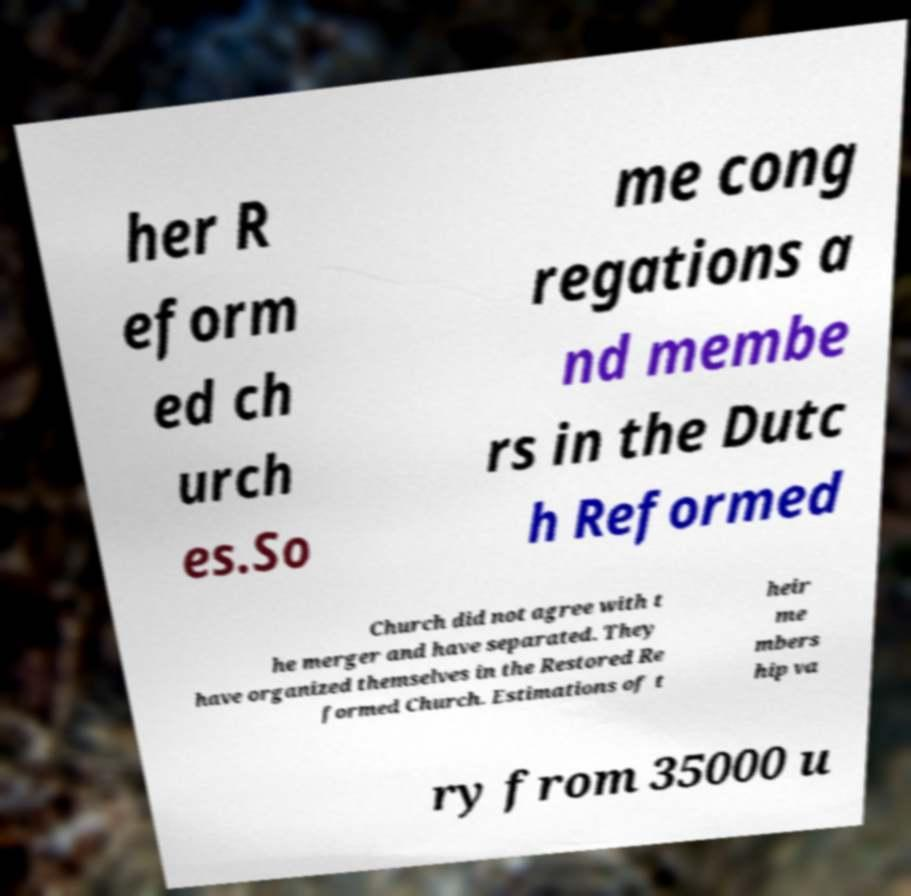Can you accurately transcribe the text from the provided image for me? her R eform ed ch urch es.So me cong regations a nd membe rs in the Dutc h Reformed Church did not agree with t he merger and have separated. They have organized themselves in the Restored Re formed Church. Estimations of t heir me mbers hip va ry from 35000 u 